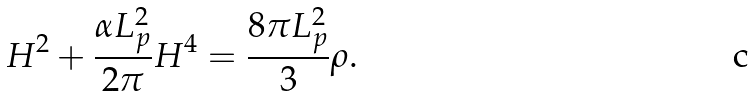<formula> <loc_0><loc_0><loc_500><loc_500>H ^ { 2 } + \frac { \alpha L _ { p } ^ { 2 } } { 2 \pi } H ^ { 4 } = \frac { 8 \pi L _ { p } ^ { 2 } } { 3 } \rho .</formula> 